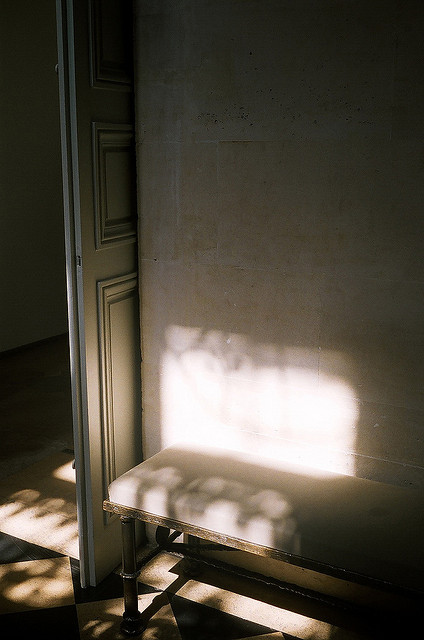<image>Where is the hinged door? The hinged door is not visible in the image. However, it could be on the left side. Where is the hinged door? I don't know where the hinged door is. It can be on the left side. 